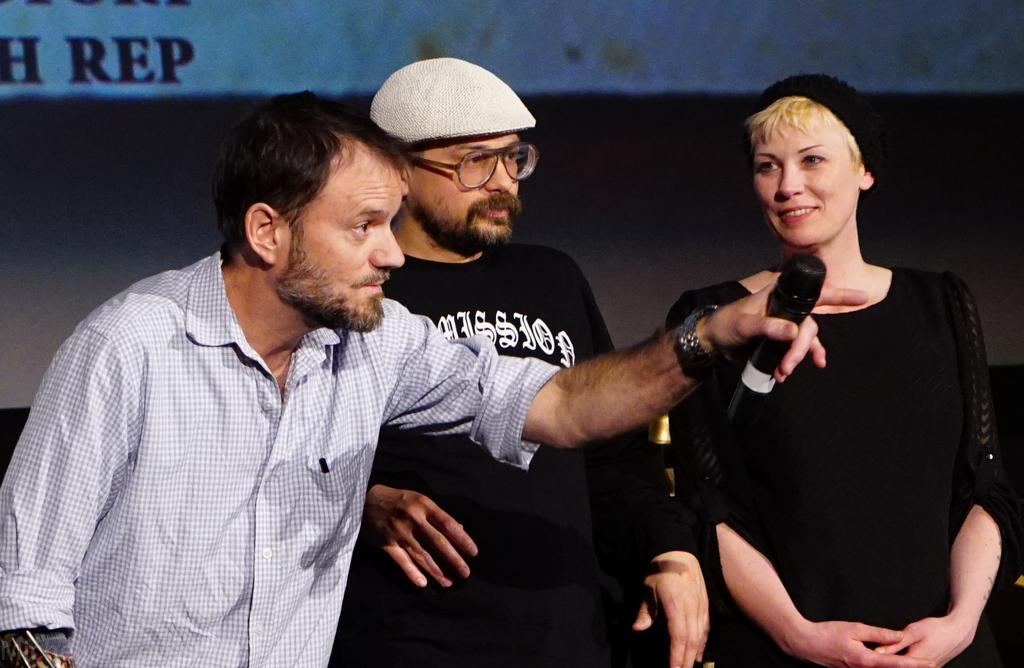How many people are in the image? There are two men and two women in the image. What are the men and women doing in the image? The men and women are standing in the front. Can you describe the man on the left side of the image? The man on the left side of the image is holding a mic. What is on the wall behind the people in the image? There is a screen on the wall behind them. What type of cake is being cut by the man on the right side of the image? There is no cake present in the image; the man on the right side is not cutting a cake. Are there any curtains visible in the image? No, there are no curtains visible in the image. 